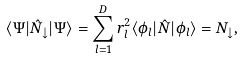Convert formula to latex. <formula><loc_0><loc_0><loc_500><loc_500>\langle \Psi | \hat { N } _ { \downarrow } | \Psi \rangle = \sum _ { l = 1 } ^ { D } r _ { l } ^ { 2 } \langle \phi _ { l } | \hat { N } | \phi _ { l } \rangle = N _ { \downarrow } ,</formula> 